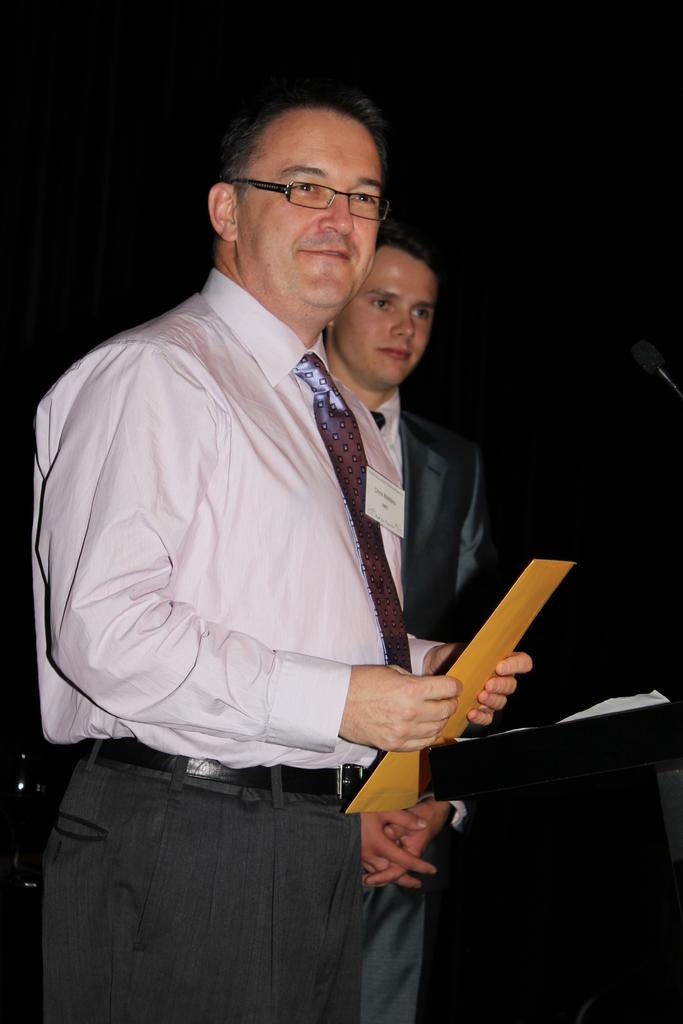How many people are in the image? There are two persons in the image. What is one person doing in the image? One person is holding an object. Can you describe the appearance of the person holding the object? The person holding the object is wearing spectacles. What is present in the image that might be used for speaking or amplifying sound? There is a microphone in the image. What structure can be seen in the image that might be used for presentations or speeches? There is a podium in the image. What type of cake is being served on the podium in the image? There is no cake present in the image; it features two persons, one holding an object, a microphone, and a podium. How many basketballs are visible on the podium in the image? There are no basketballs present in the image. 